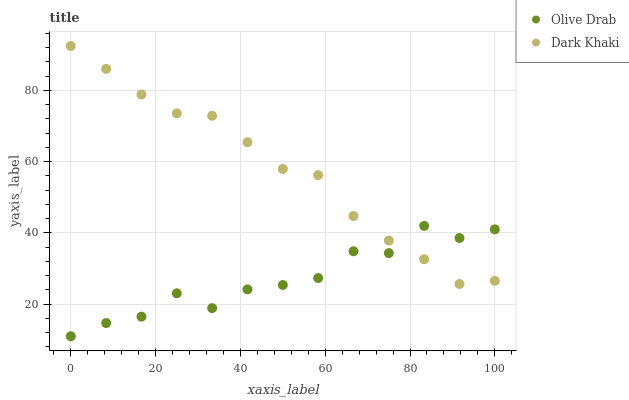Does Olive Drab have the minimum area under the curve?
Answer yes or no. Yes. Does Dark Khaki have the maximum area under the curve?
Answer yes or no. Yes. Does Olive Drab have the maximum area under the curve?
Answer yes or no. No. Is Dark Khaki the smoothest?
Answer yes or no. Yes. Is Olive Drab the roughest?
Answer yes or no. Yes. Is Olive Drab the smoothest?
Answer yes or no. No. Does Olive Drab have the lowest value?
Answer yes or no. Yes. Does Dark Khaki have the highest value?
Answer yes or no. Yes. Does Olive Drab have the highest value?
Answer yes or no. No. Does Olive Drab intersect Dark Khaki?
Answer yes or no. Yes. Is Olive Drab less than Dark Khaki?
Answer yes or no. No. Is Olive Drab greater than Dark Khaki?
Answer yes or no. No. 